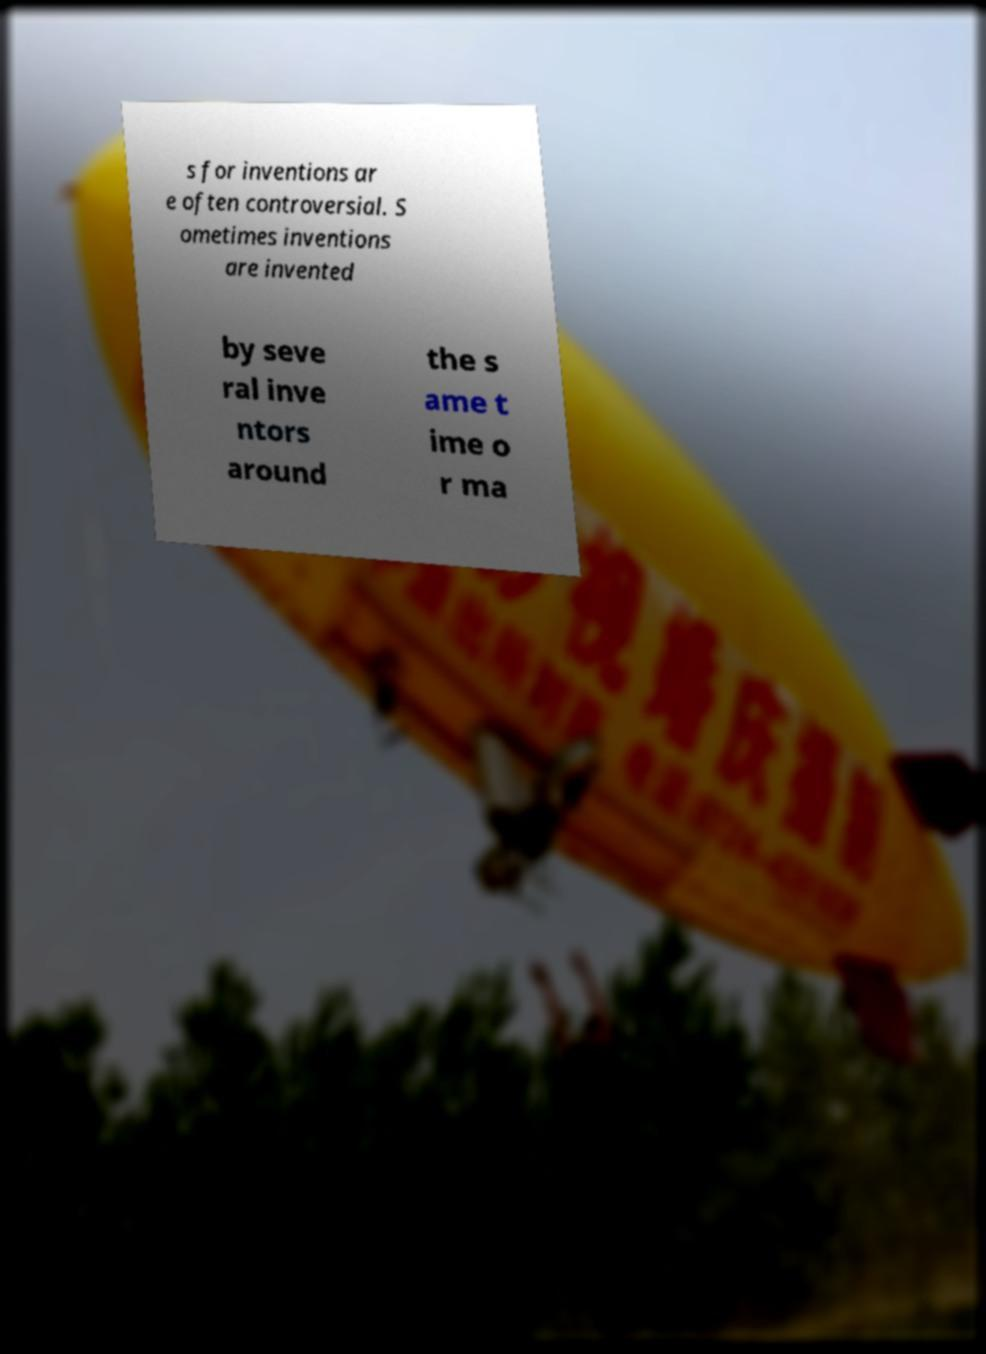For documentation purposes, I need the text within this image transcribed. Could you provide that? s for inventions ar e often controversial. S ometimes inventions are invented by seve ral inve ntors around the s ame t ime o r ma 